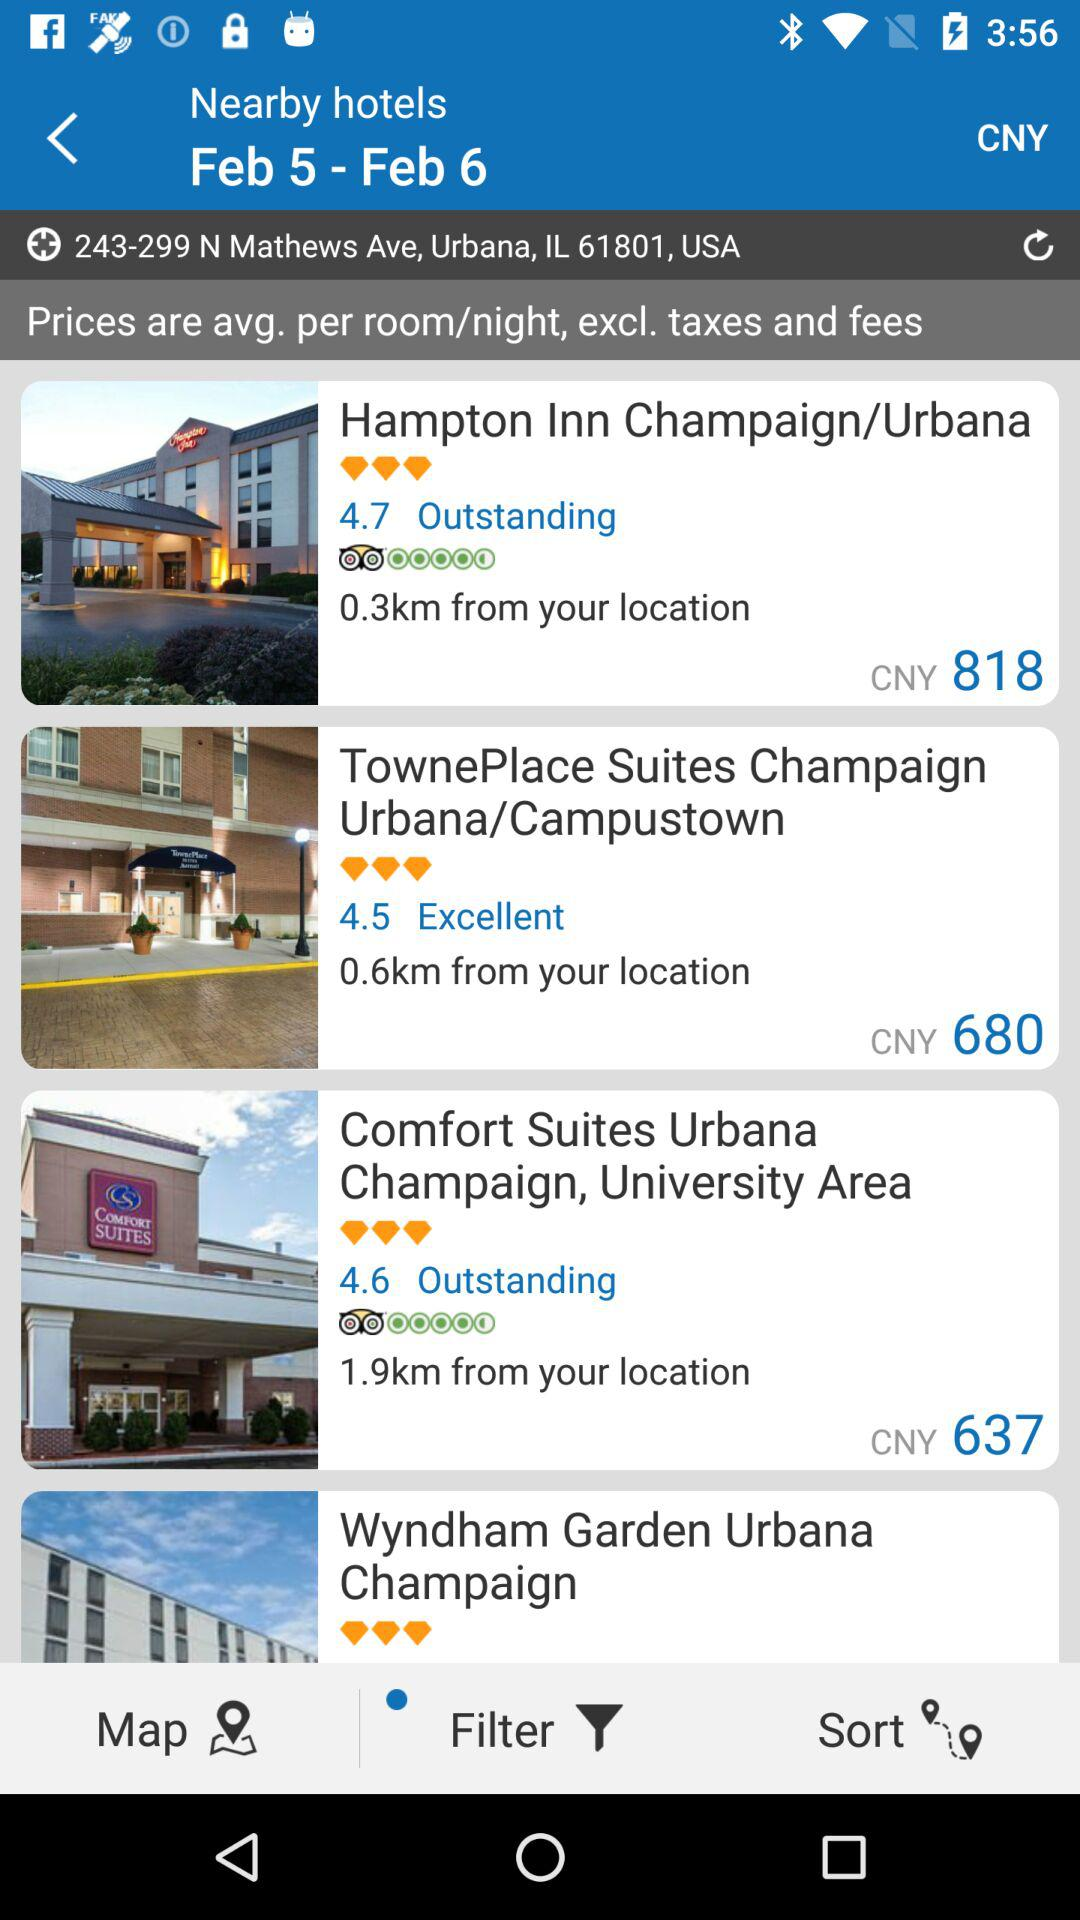What is the distance between "Hampton Inn Champaign/Urbana" and my location? The distance between "Hampton Inn Champaign/Urbana" and your location is 0.3km. 